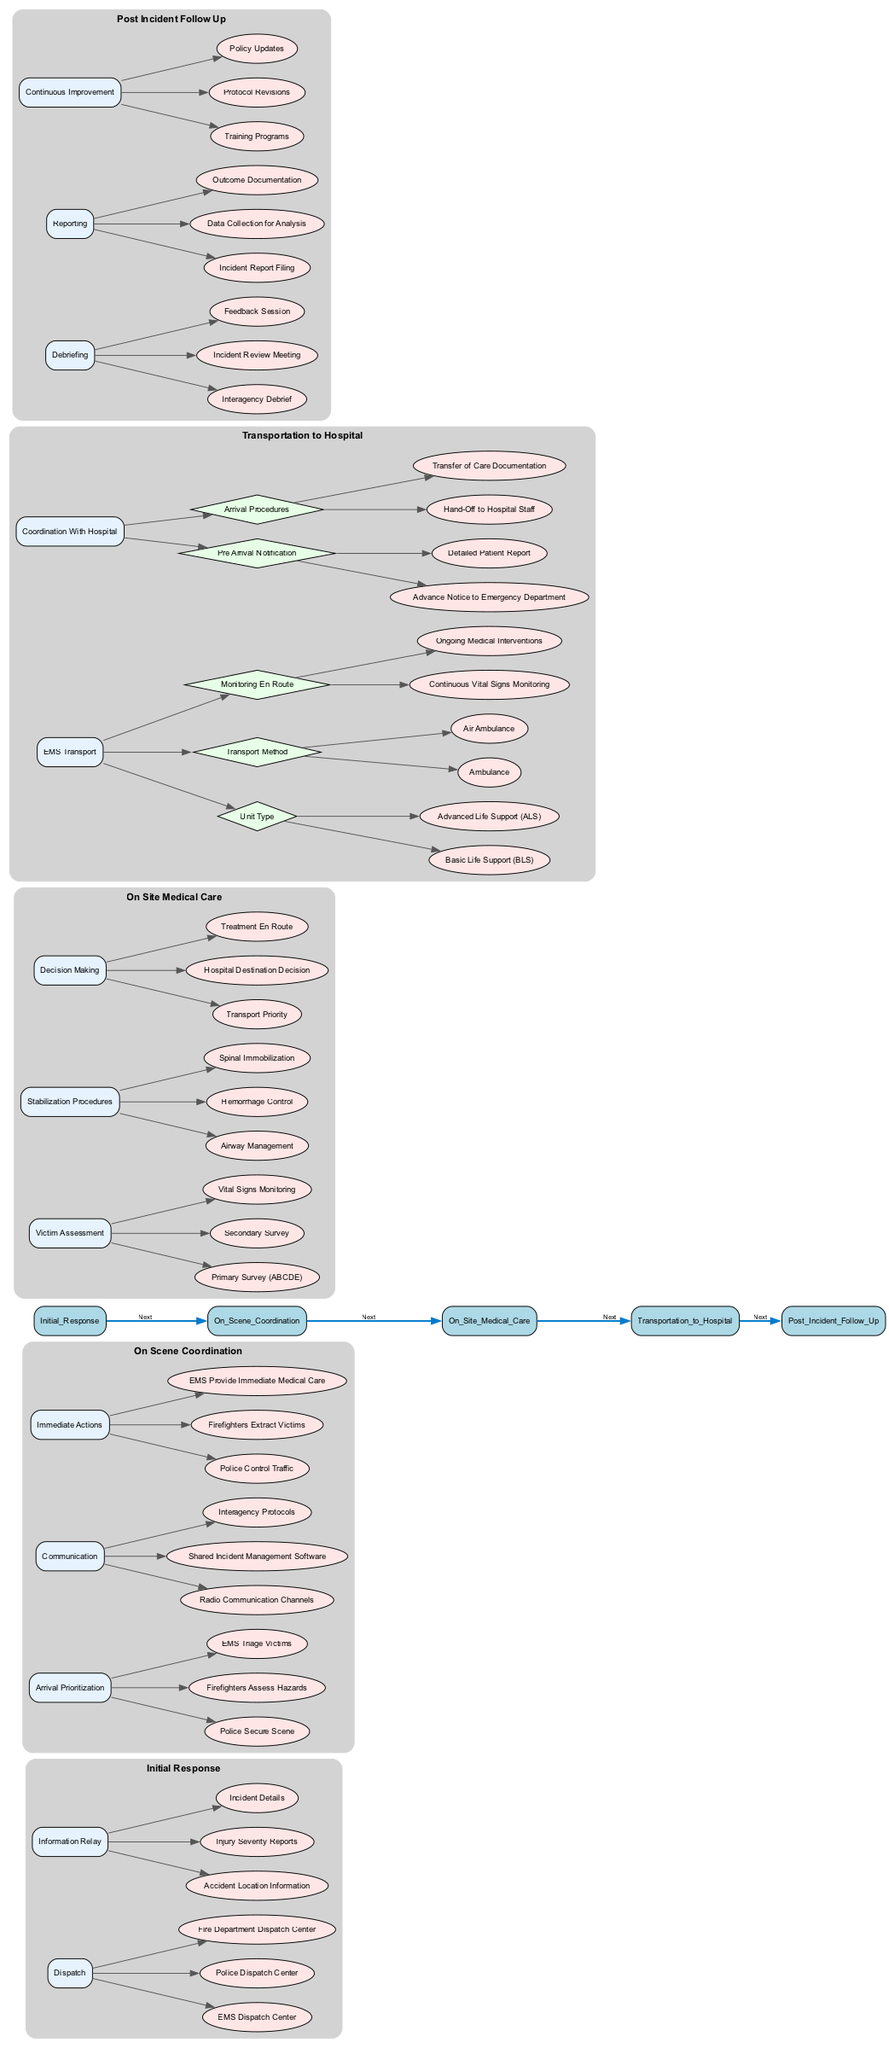What are the three main dispatch centers involved in the initial response? The diagram indicates that the initial response involves three main dispatch centers: the EMS Dispatch Center, the Police Dispatch Center, and the Fire Department Dispatch Center.
Answer: EMS Dispatch Center, Police Dispatch Center, Fire Department Dispatch Center What are the immediate actions taken by law enforcement at the accident scene? According to the diagram, the immediate actions taken by law enforcement at the accident scene include controlling traffic. This is one of the specific tasks assigned to police in the "Immediate Actions" section.
Answer: Control Traffic How many types of EMS transport units are mentioned in the pathway? The diagram shows two types of EMS transport units listed under the "EMS Transport" section: Basic Life Support (BLS) and Advanced Life Support (ALS). Therefore, the total is two.
Answer: 2 What is the first action described in the 'On Scene Coordination' stage? In the 'On Scene Coordination' stage, the first action listed is for the police to secure the scene, which is the initial task performed after arriving at the accident site.
Answer: Police Secure Scene Which communication method facilitates the coordination between services on the scene? The diagram specifies "Radio Communication Channels" as one of the methods for communication facilitating coordination between EMS, law enforcement, and fire services at the accident scene.
Answer: Radio Communication Channels What procedures are involved in the stabilization of victims? The 'Stabilization Procedures' section in the 'On Site Medical Care' stage includes three actions: Airway Management, Hemorrhage Control, and Spinal Immobilization, all aimed at stabilizing victims before transport.
Answer: Airway Management, Hemorrhage Control, Spinal Immobilization How does post-incident follow-up contribute to continuous improvement? The "Continuous Improvement" actions in the 'Post Incident Follow Up' stage highlight methods for enhancing future responses, which include training programs, protocol revisions, and policy updates based on the learning from the incidents.
Answer: Training Programs, Protocol Revisions, Policy Updates What is included in the pre-arrival notification to the hospital? The pre-arrival notification section specifies that it includes Advance Notice to Emergency Department and a Detailed Patient Report to ensure the emergency department is prepared for the incoming patient.
Answer: Advance Notice to Emergency Department, Detailed Patient Report 